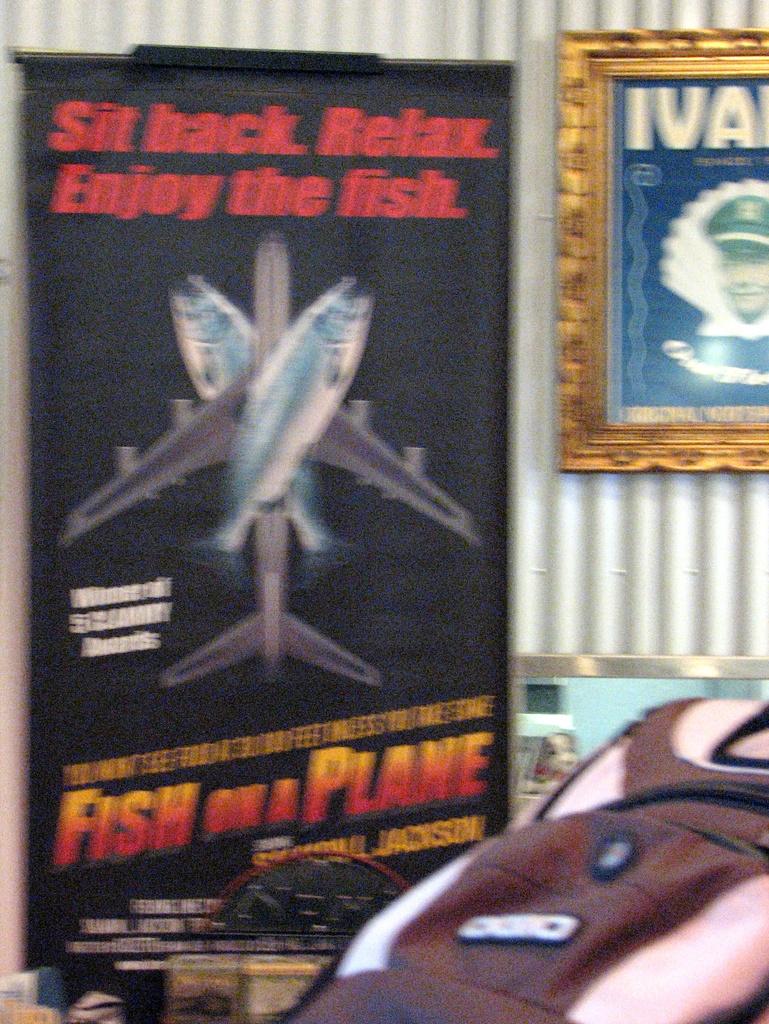What is the title of the film on the poster?
Make the answer very short. Fish on a plane. 